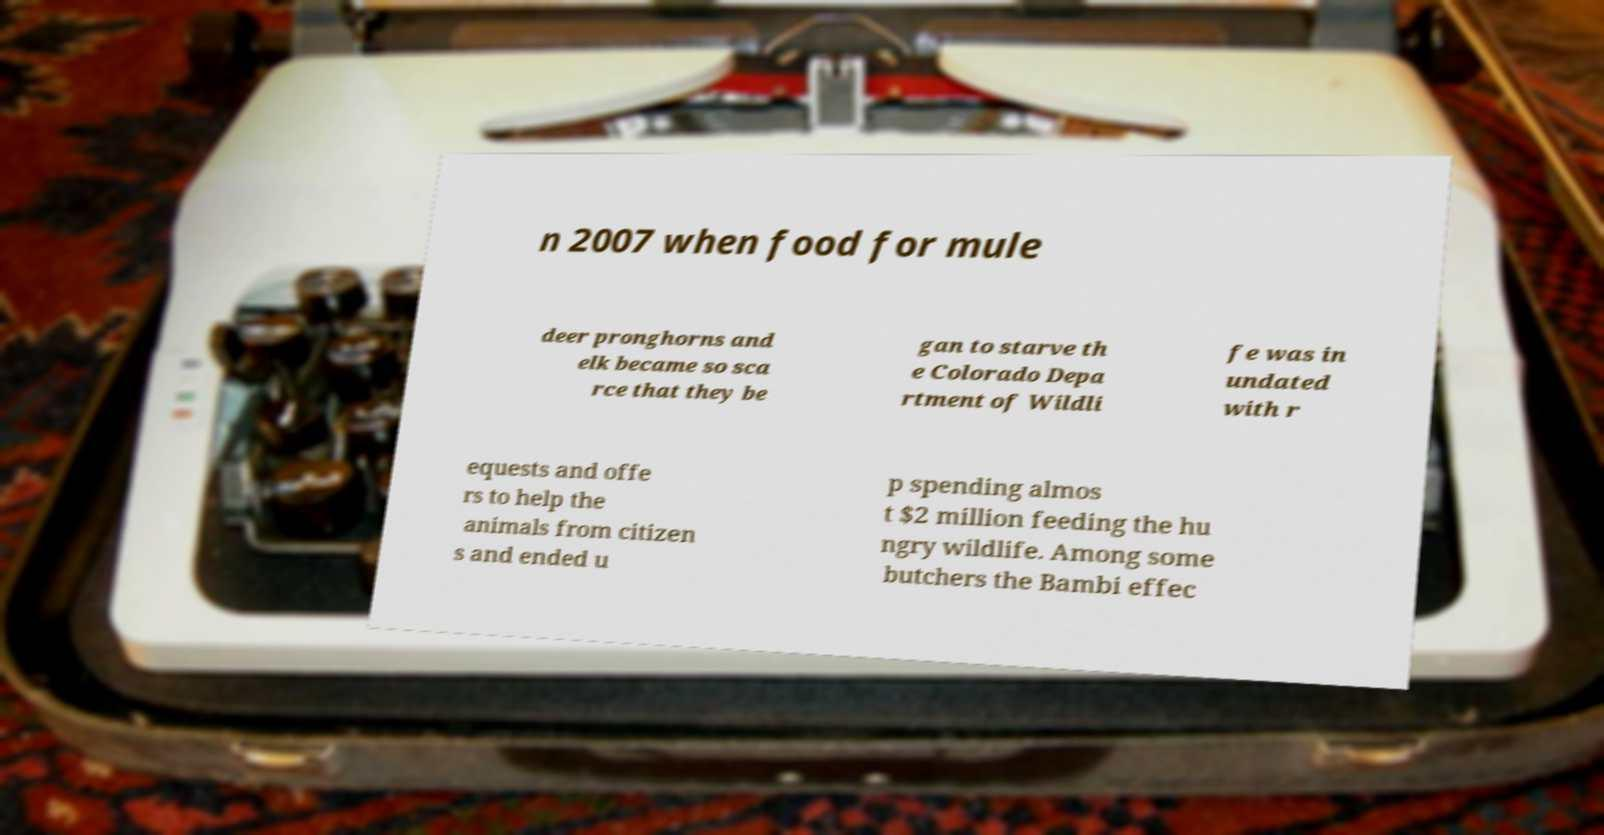Please identify and transcribe the text found in this image. n 2007 when food for mule deer pronghorns and elk became so sca rce that they be gan to starve th e Colorado Depa rtment of Wildli fe was in undated with r equests and offe rs to help the animals from citizen s and ended u p spending almos t $2 million feeding the hu ngry wildlife. Among some butchers the Bambi effec 